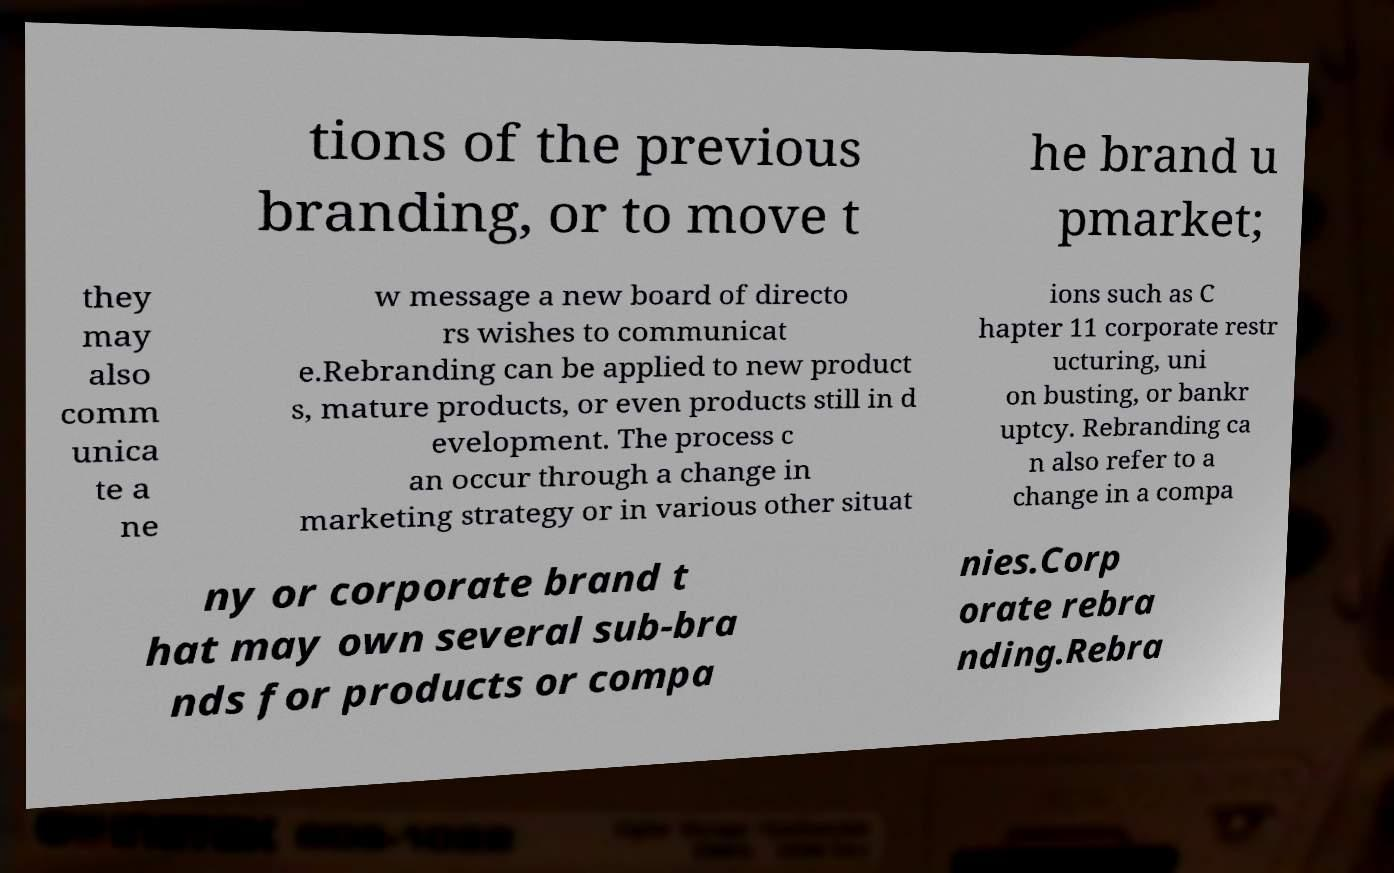Could you assist in decoding the text presented in this image and type it out clearly? tions of the previous branding, or to move t he brand u pmarket; they may also comm unica te a ne w message a new board of directo rs wishes to communicat e.Rebranding can be applied to new product s, mature products, or even products still in d evelopment. The process c an occur through a change in marketing strategy or in various other situat ions such as C hapter 11 corporate restr ucturing, uni on busting, or bankr uptcy. Rebranding ca n also refer to a change in a compa ny or corporate brand t hat may own several sub-bra nds for products or compa nies.Corp orate rebra nding.Rebra 